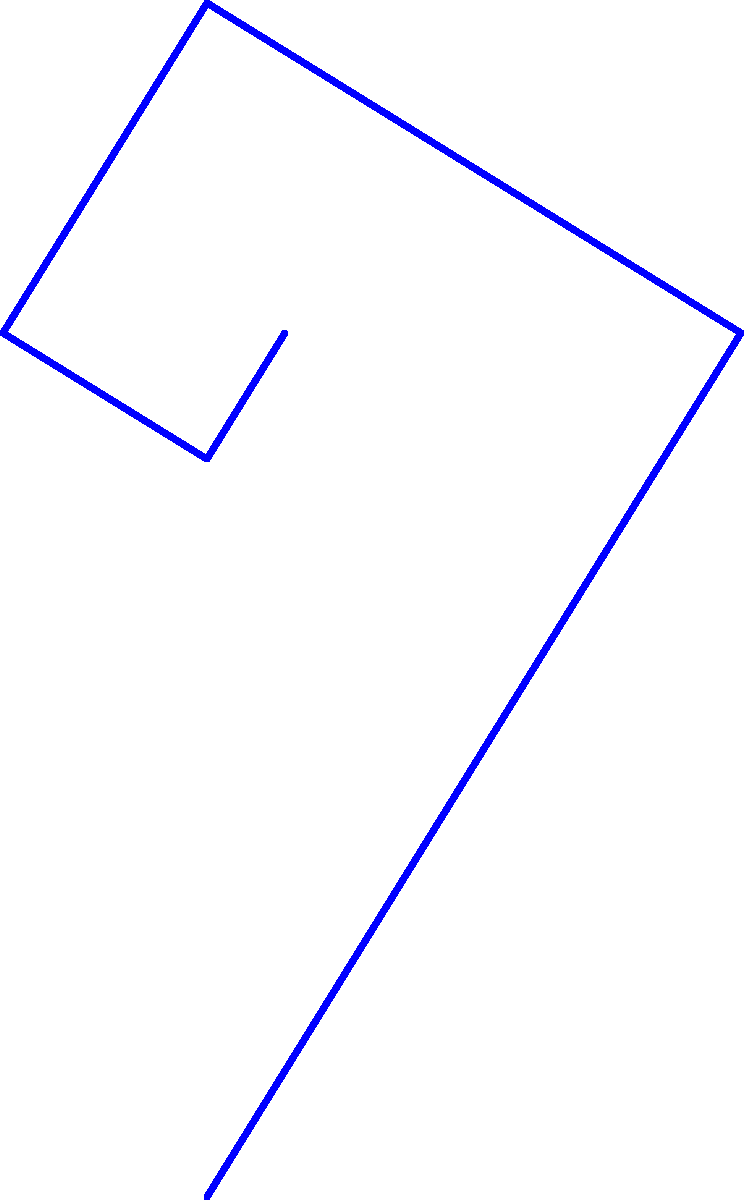In the diagram, a golden rectangle is shown with a golden spiral inscribed within it. If the length of the longer side of the rectangle is $a$, what is the length of the shorter side in terms of $a$? To find the length of the shorter side of the golden rectangle, we need to follow these steps:

1. Recall that in a golden rectangle, the ratio of the longer side to the shorter side is equal to the golden ratio, φ (phi).

2. The golden ratio is defined as: $φ = \frac{1 + \sqrt{5}}{2} ≈ 1.618033988749895$

3. In our case, if $a$ is the longer side and $b$ is the shorter side, we can express this relationship as:

   $\frac{a}{b} = φ$

4. To find $b$ in terms of $a$, we can rearrange this equation:

   $b = \frac{a}{φ}$

5. Substituting the value of φ:

   $b = \frac{a}{\frac{1 + \sqrt{5}}{2}}$

6. Simplifying this expression:

   $b = \frac{2a}{1 + \sqrt{5}}$

7. Multiplying both numerator and denominator by $(1 - \sqrt{5})$:

   $b = \frac{2a(1 - \sqrt{5})}{(1 + \sqrt{5})(1 - \sqrt{5})} = \frac{2a(1 - \sqrt{5})}{1 - 5} = \frac{2a(1 - \sqrt{5})}{-4}$

8. Simplifying further:

   $b = \frac{a(\sqrt{5} - 1)}{2}$

Therefore, the length of the shorter side of the golden rectangle is $\frac{a(\sqrt{5} - 1)}{2}$.
Answer: $\frac{a(\sqrt{5} - 1)}{2}$ 